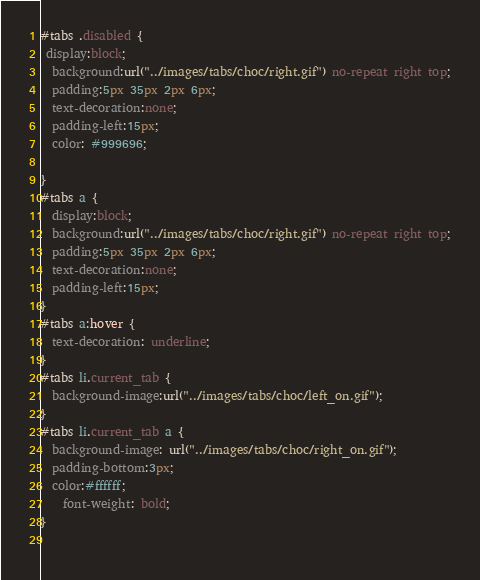Convert code to text. <code><loc_0><loc_0><loc_500><loc_500><_CSS_>#tabs .disabled {
 display:block;
  background:url("../images/tabs/choc/right.gif") no-repeat right top;
  padding:5px 35px 2px 6px; 
  text-decoration:none;
  padding-left:15px;
  color: #999696;

}
#tabs a {
  display:block;
  background:url("../images/tabs/choc/right.gif") no-repeat right top;
  padding:5px 35px 2px 6px; 
  text-decoration:none;
  padding-left:15px;
}
#tabs a:hover {
  text-decoration: underline;
}
#tabs li.current_tab {
  background-image:url("../images/tabs/choc/left_on.gif");
}
#tabs li.current_tab a {
  background-image: url("../images/tabs/choc/right_on.gif");
  padding-bottom:3px; 
  color:#ffffff;
    font-weight: bold;
}
 
</code> 